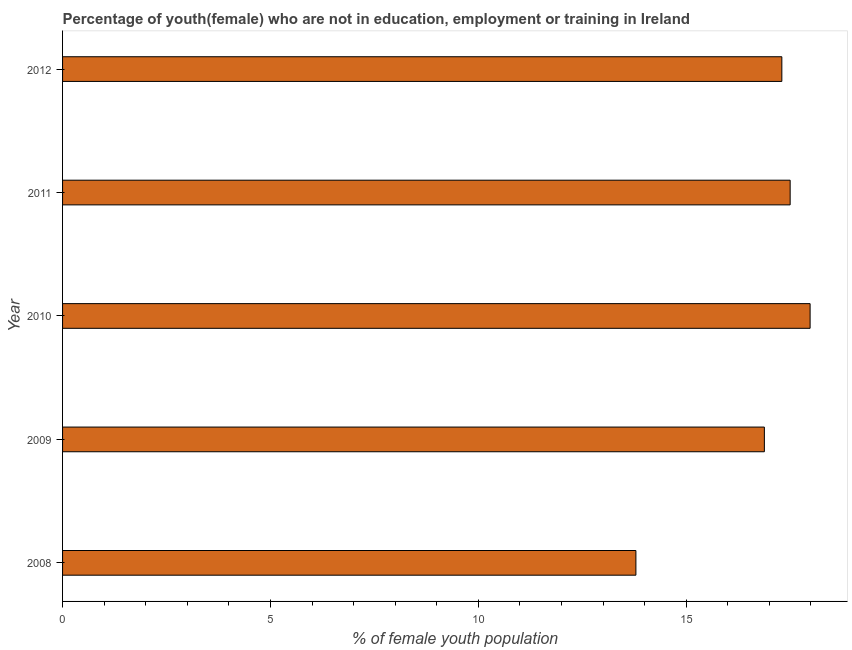Does the graph contain grids?
Provide a succinct answer. No. What is the title of the graph?
Offer a terse response. Percentage of youth(female) who are not in education, employment or training in Ireland. What is the label or title of the X-axis?
Ensure brevity in your answer.  % of female youth population. What is the label or title of the Y-axis?
Keep it short and to the point. Year. What is the unemployed female youth population in 2012?
Keep it short and to the point. 17.3. Across all years, what is the maximum unemployed female youth population?
Keep it short and to the point. 17.98. Across all years, what is the minimum unemployed female youth population?
Your response must be concise. 13.79. What is the sum of the unemployed female youth population?
Ensure brevity in your answer.  83.45. What is the difference between the unemployed female youth population in 2009 and 2011?
Provide a short and direct response. -0.62. What is the average unemployed female youth population per year?
Provide a succinct answer. 16.69. What is the median unemployed female youth population?
Provide a succinct answer. 17.3. In how many years, is the unemployed female youth population greater than 13 %?
Your response must be concise. 5. What is the ratio of the unemployed female youth population in 2008 to that in 2010?
Ensure brevity in your answer.  0.77. Is the difference between the unemployed female youth population in 2009 and 2012 greater than the difference between any two years?
Make the answer very short. No. What is the difference between the highest and the second highest unemployed female youth population?
Keep it short and to the point. 0.48. What is the difference between the highest and the lowest unemployed female youth population?
Offer a terse response. 4.19. How many years are there in the graph?
Keep it short and to the point. 5. What is the difference between two consecutive major ticks on the X-axis?
Ensure brevity in your answer.  5. Are the values on the major ticks of X-axis written in scientific E-notation?
Your answer should be compact. No. What is the % of female youth population in 2008?
Your response must be concise. 13.79. What is the % of female youth population in 2009?
Your answer should be very brief. 16.88. What is the % of female youth population in 2010?
Provide a succinct answer. 17.98. What is the % of female youth population of 2012?
Offer a terse response. 17.3. What is the difference between the % of female youth population in 2008 and 2009?
Make the answer very short. -3.09. What is the difference between the % of female youth population in 2008 and 2010?
Provide a succinct answer. -4.19. What is the difference between the % of female youth population in 2008 and 2011?
Make the answer very short. -3.71. What is the difference between the % of female youth population in 2008 and 2012?
Your response must be concise. -3.51. What is the difference between the % of female youth population in 2009 and 2010?
Provide a short and direct response. -1.1. What is the difference between the % of female youth population in 2009 and 2011?
Offer a terse response. -0.62. What is the difference between the % of female youth population in 2009 and 2012?
Provide a short and direct response. -0.42. What is the difference between the % of female youth population in 2010 and 2011?
Offer a very short reply. 0.48. What is the difference between the % of female youth population in 2010 and 2012?
Ensure brevity in your answer.  0.68. What is the ratio of the % of female youth population in 2008 to that in 2009?
Your response must be concise. 0.82. What is the ratio of the % of female youth population in 2008 to that in 2010?
Your answer should be compact. 0.77. What is the ratio of the % of female youth population in 2008 to that in 2011?
Your response must be concise. 0.79. What is the ratio of the % of female youth population in 2008 to that in 2012?
Provide a succinct answer. 0.8. What is the ratio of the % of female youth population in 2009 to that in 2010?
Your answer should be very brief. 0.94. What is the ratio of the % of female youth population in 2010 to that in 2012?
Give a very brief answer. 1.04. 